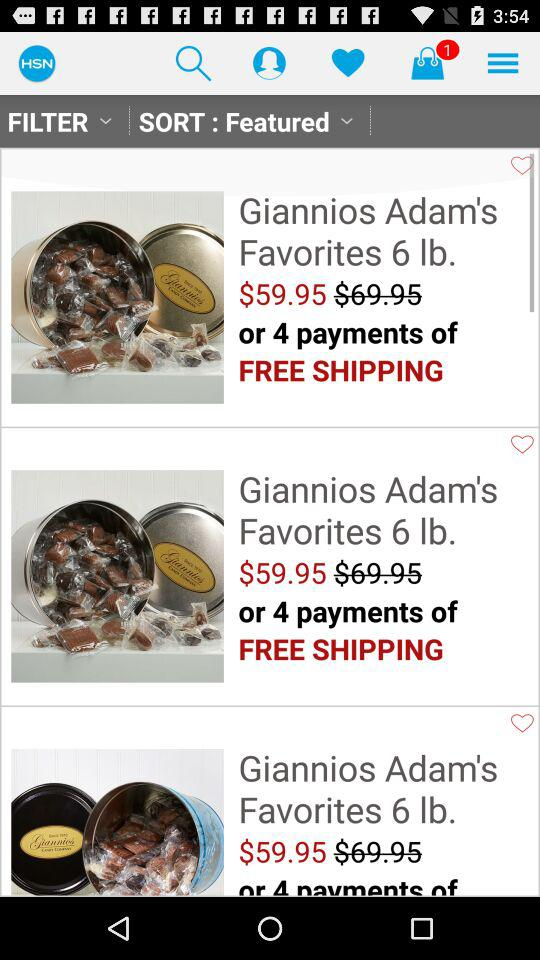How many unread message are there?
When the provided information is insufficient, respond with <no answer>. <no answer> 